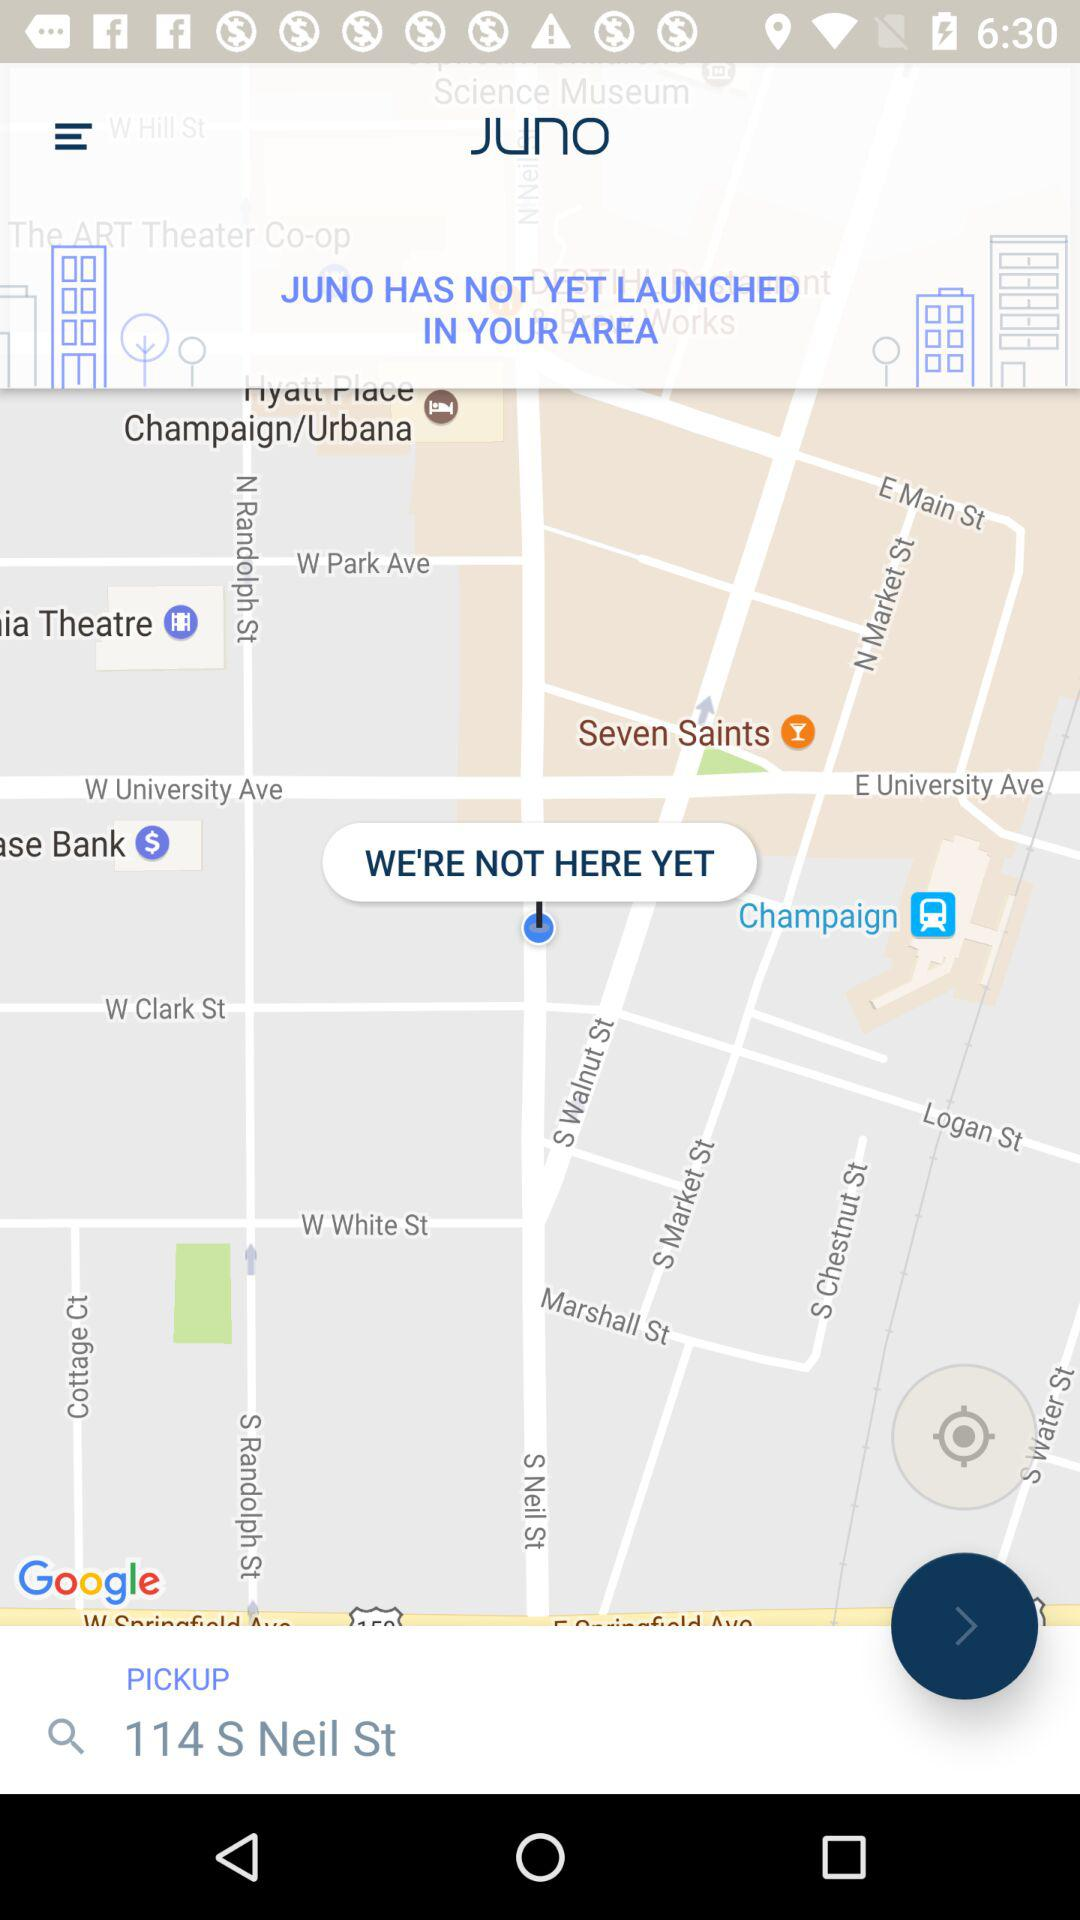What has not yet launched in the area? In the area, "JUNO" has not yet launched. 